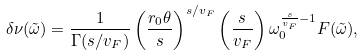Convert formula to latex. <formula><loc_0><loc_0><loc_500><loc_500>\delta \nu ( \tilde { \omega } ) = \frac { 1 } { \Gamma ( s / v _ { F } ) } \left ( \frac { r _ { 0 } \theta } { s } \right ) ^ { s / v _ { F } } \left ( \frac { s } { v _ { F } } \right ) \omega _ { 0 } ^ { \frac { s } { v _ { F } } - 1 } F ( \tilde { \omega } ) ,</formula> 